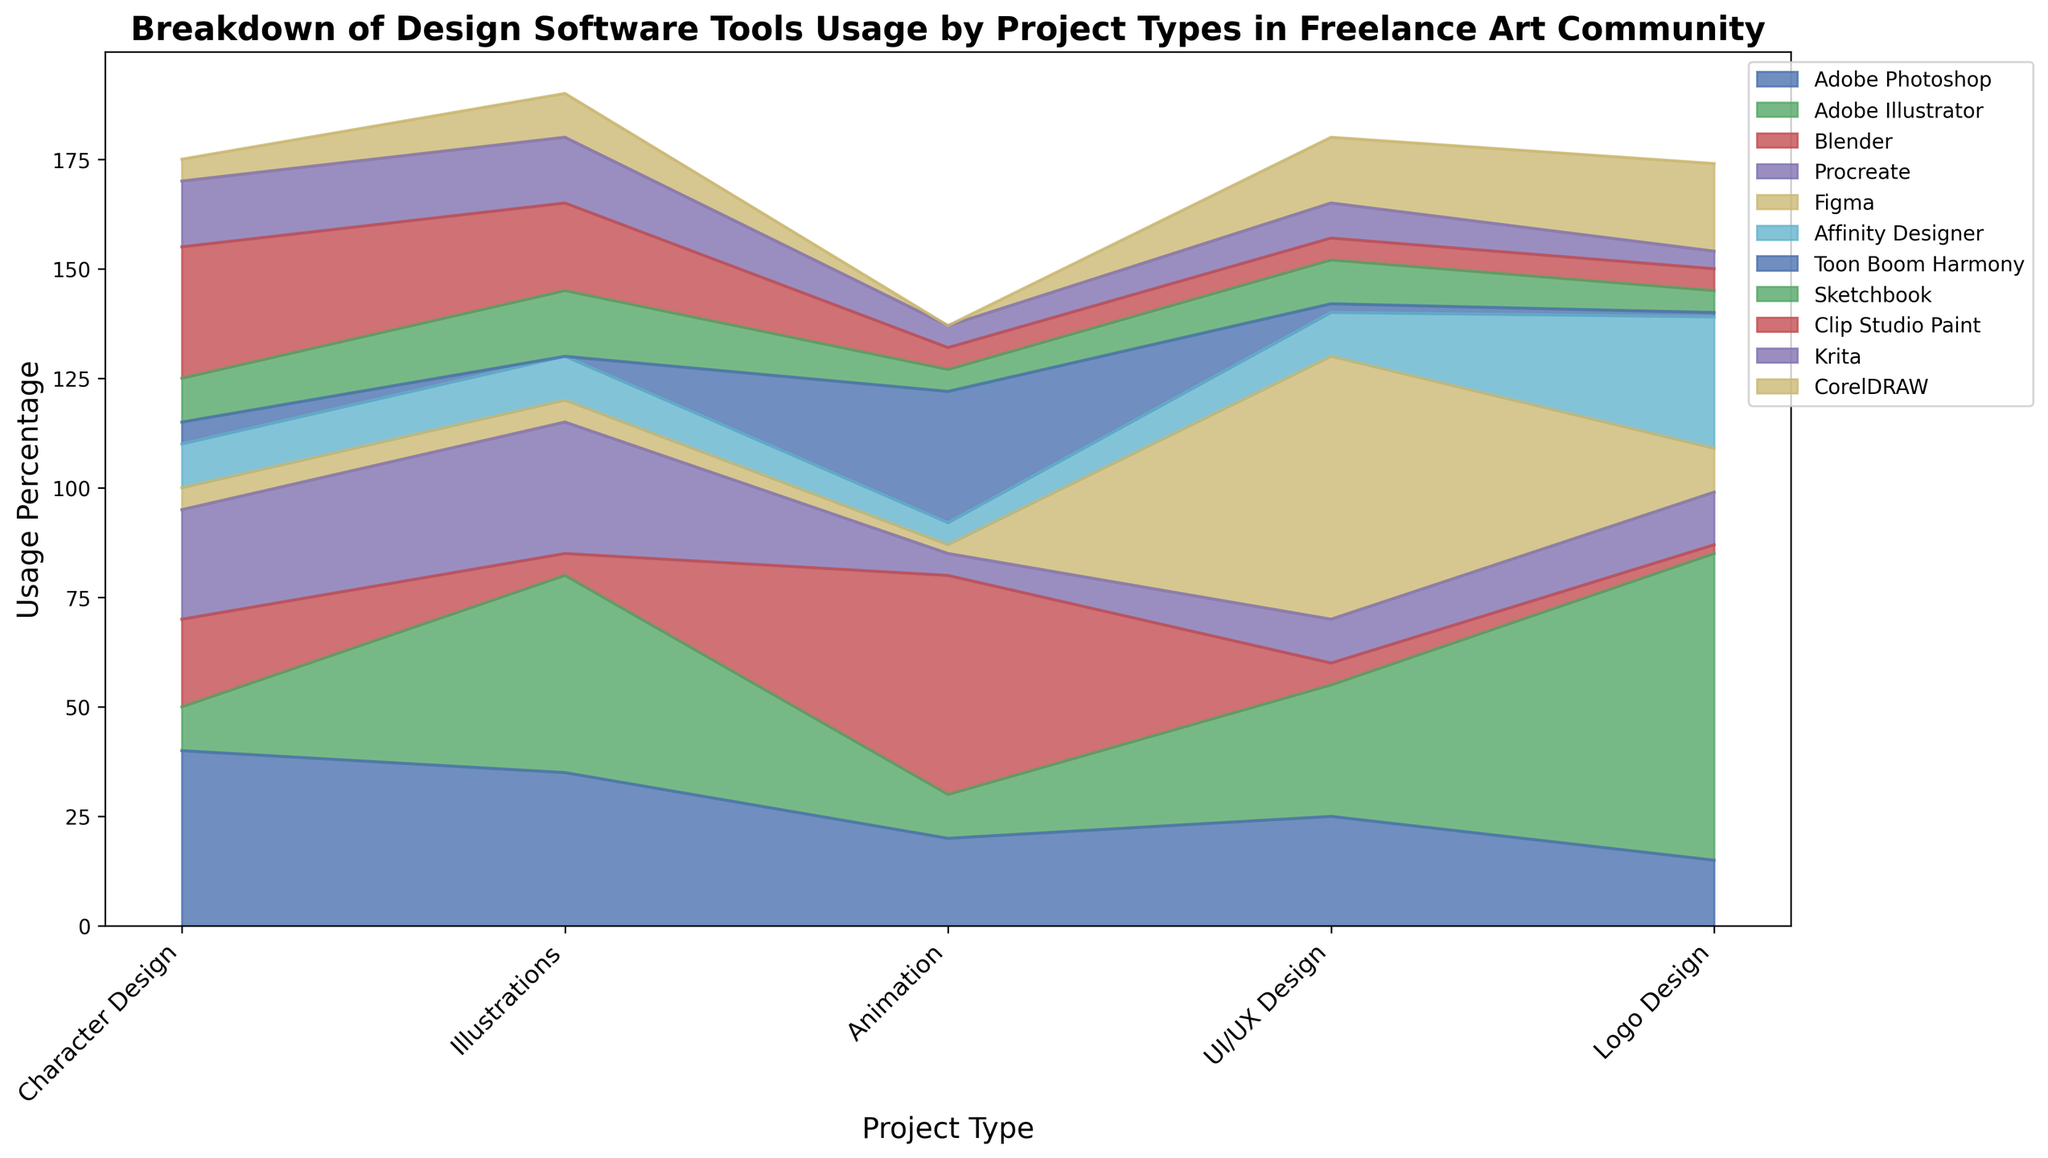How is the usage of Blender distributed across different project types? Looking at the area chart, we observe that Blender has higher usage in Animation projects and minimal in UI/UX Design, Logo Design, and Illustrations. Overall, its usage is predominantly concentrated in Animation.
Answer: Predominantly in Animation Between Adobe Photoshop and Krita, which software is used more for UI/UX Design? Adobe Photoshop and Krita both have an area segment for UI/UX Design. Adobe Photoshop has an area segment of about 25%, whereas Krita's segment is smaller, around 8%. This indicates that Adobe Photoshop is used more for UI/UX Design.
Answer: Adobe Photoshop Which software has the largest usage in Logo Design, and what is the approximate percentage? Observing the area chart, we see Adobe Illustrator has the tallest area segment in Logo Design. The corresponding percentage is around 70%.
Answer: Adobe Illustrator, 70% For Character Design projects, which software tools have almost equal usage, and what is the approximate percentage? By examining the area chart, Procreate and Adobe Photoshop have comparable size segments for Character Design projects, both around 25-40%.
Answer: Adobe Photoshop and Procreate What is the total percentage usage of Toon Boom Harmony across all project types? To find the total percentage, we sum Toon Boom Harmony's usage percentages: 5 + 0 + 30 + 2 + 1 equals 38. Therefore, the total usage percentage is 38%.
Answer: 38% How does the usage of Clip Studio Paint compare to Sketchbook for Illustrations? Looking at the chart, Clip Studio Paint has a segment around 20%, while Sketchbook has a segment around 15% for Illustrations. Thus, Clip Studio Paint is used more than Sketchbook.
Answer: Clip Studio Paint is used more For UI/UX Design, which tools have less than 10% usage, and what are their corresponding percentages? The area chart shows that Blender, Procreate, Toon Boom Harmony, Sketchbook, and Clip Studio Paint have segments lower than 10% for UI/UX Design. Their respective percentages are approximately 5%, 10%, 2%, 10%, and 5%.
Answer: Blender - 5%, Procreate - 10%, Toon Boom Harmony - 2%, Sketchbook - 10%, Clip Studio Paint - 5% Which project type sees nearly equivalent usage of Figma and Adobe Illustrator, and what are the percentages? For UI/UX Design, Figma and Adobe Illustrator have similar segments. Figma is around 60%, and Adobe Illustrator is about 30%. These percentages are significant but less equal when compared to higher percentages.
Answer: Figma - 60%, Adobe Illustrator - 30% What is the average usage percentage of Adobe Illustrator across all project types? To find the average, add Adobe Illustrator's usage percentages and divide by the number of project types. The sum is 10 + 45 + 10 + 30 + 70 = 165. Dividing by 5 project types, we get an average of 165 / 5 = 33%.
Answer: 33% If Procreate's usage in Animation doubles, what would be its new usage percentage? Procreate's current usage in Animation is 5%. Doubling this would make it 5 * 2 = 10%.
Answer: 10% 